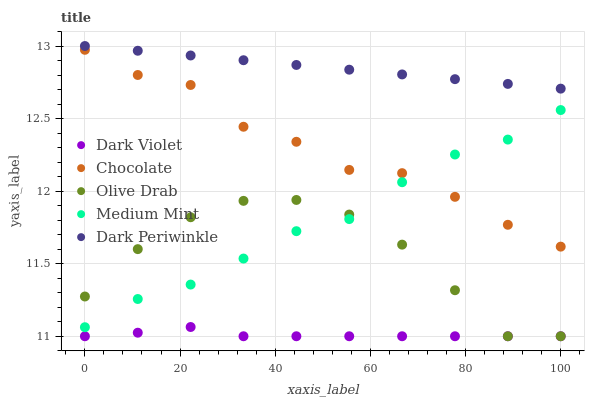Does Dark Violet have the minimum area under the curve?
Answer yes or no. Yes. Does Dark Periwinkle have the maximum area under the curve?
Answer yes or no. Yes. Does Olive Drab have the minimum area under the curve?
Answer yes or no. No. Does Olive Drab have the maximum area under the curve?
Answer yes or no. No. Is Dark Periwinkle the smoothest?
Answer yes or no. Yes. Is Chocolate the roughest?
Answer yes or no. Yes. Is Olive Drab the smoothest?
Answer yes or no. No. Is Olive Drab the roughest?
Answer yes or no. No. Does Olive Drab have the lowest value?
Answer yes or no. Yes. Does Dark Periwinkle have the lowest value?
Answer yes or no. No. Does Dark Periwinkle have the highest value?
Answer yes or no. Yes. Does Olive Drab have the highest value?
Answer yes or no. No. Is Dark Violet less than Medium Mint?
Answer yes or no. Yes. Is Chocolate greater than Olive Drab?
Answer yes or no. Yes. Does Chocolate intersect Medium Mint?
Answer yes or no. Yes. Is Chocolate less than Medium Mint?
Answer yes or no. No. Is Chocolate greater than Medium Mint?
Answer yes or no. No. Does Dark Violet intersect Medium Mint?
Answer yes or no. No. 